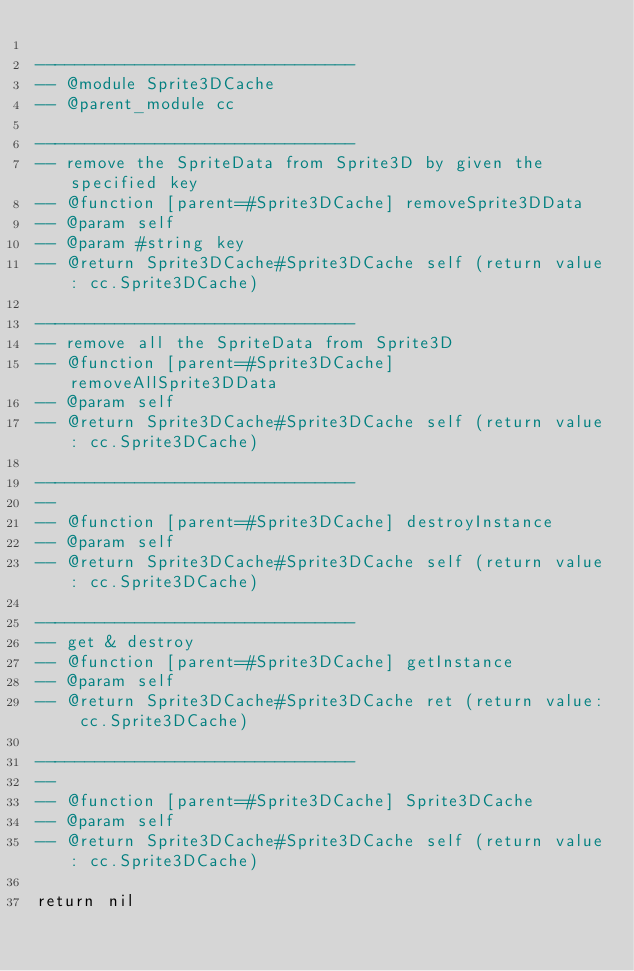<code> <loc_0><loc_0><loc_500><loc_500><_Lua_>
--------------------------------
-- @module Sprite3DCache
-- @parent_module cc

--------------------------------
-- remove the SpriteData from Sprite3D by given the specified key
-- @function [parent=#Sprite3DCache] removeSprite3DData 
-- @param self
-- @param #string key
-- @return Sprite3DCache#Sprite3DCache self (return value: cc.Sprite3DCache)
        
--------------------------------
-- remove all the SpriteData from Sprite3D
-- @function [parent=#Sprite3DCache] removeAllSprite3DData 
-- @param self
-- @return Sprite3DCache#Sprite3DCache self (return value: cc.Sprite3DCache)
        
--------------------------------
-- 
-- @function [parent=#Sprite3DCache] destroyInstance 
-- @param self
-- @return Sprite3DCache#Sprite3DCache self (return value: cc.Sprite3DCache)
        
--------------------------------
-- get & destroy
-- @function [parent=#Sprite3DCache] getInstance 
-- @param self
-- @return Sprite3DCache#Sprite3DCache ret (return value: cc.Sprite3DCache)
        
--------------------------------
-- 
-- @function [parent=#Sprite3DCache] Sprite3DCache 
-- @param self
-- @return Sprite3DCache#Sprite3DCache self (return value: cc.Sprite3DCache)
        
return nil
</code> 